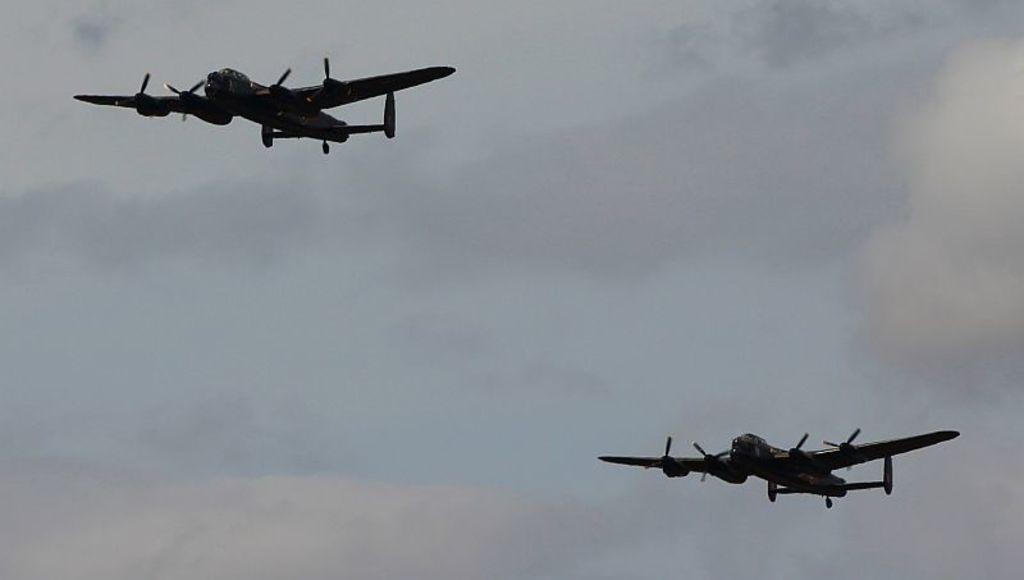How would you summarize this image in a sentence or two? In this picture we can see two airplanes and the cloudy sky in the background. 